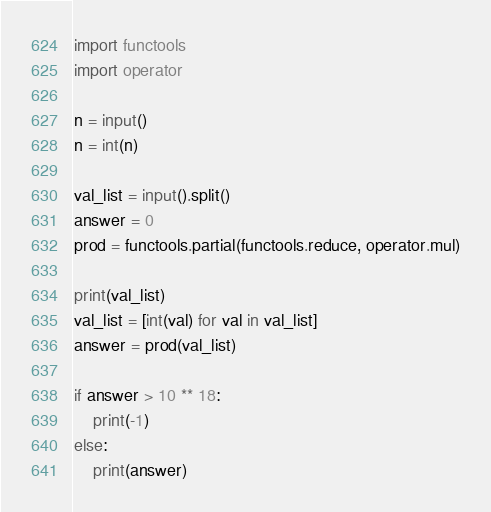Convert code to text. <code><loc_0><loc_0><loc_500><loc_500><_Python_>import functools
import operator

n = input()
n = int(n)

val_list = input().split()
answer = 0
prod = functools.partial(functools.reduce, operator.mul)

print(val_list)
val_list = [int(val) for val in val_list]
answer = prod(val_list)

if answer > 10 ** 18:
    print(-1)
else:
    print(answer)

</code> 